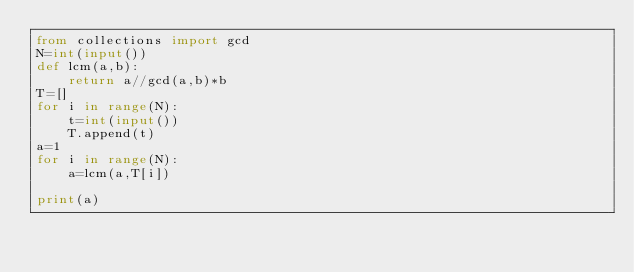<code> <loc_0><loc_0><loc_500><loc_500><_Python_>from collections import gcd
N=int(input())
def lcm(a,b):
    return a//gcd(a,b)*b
T=[]
for i in range(N):
    t=int(input())
    T.append(t)
a=1
for i in range(N):
    a=lcm(a,T[i])

print(a)</code> 